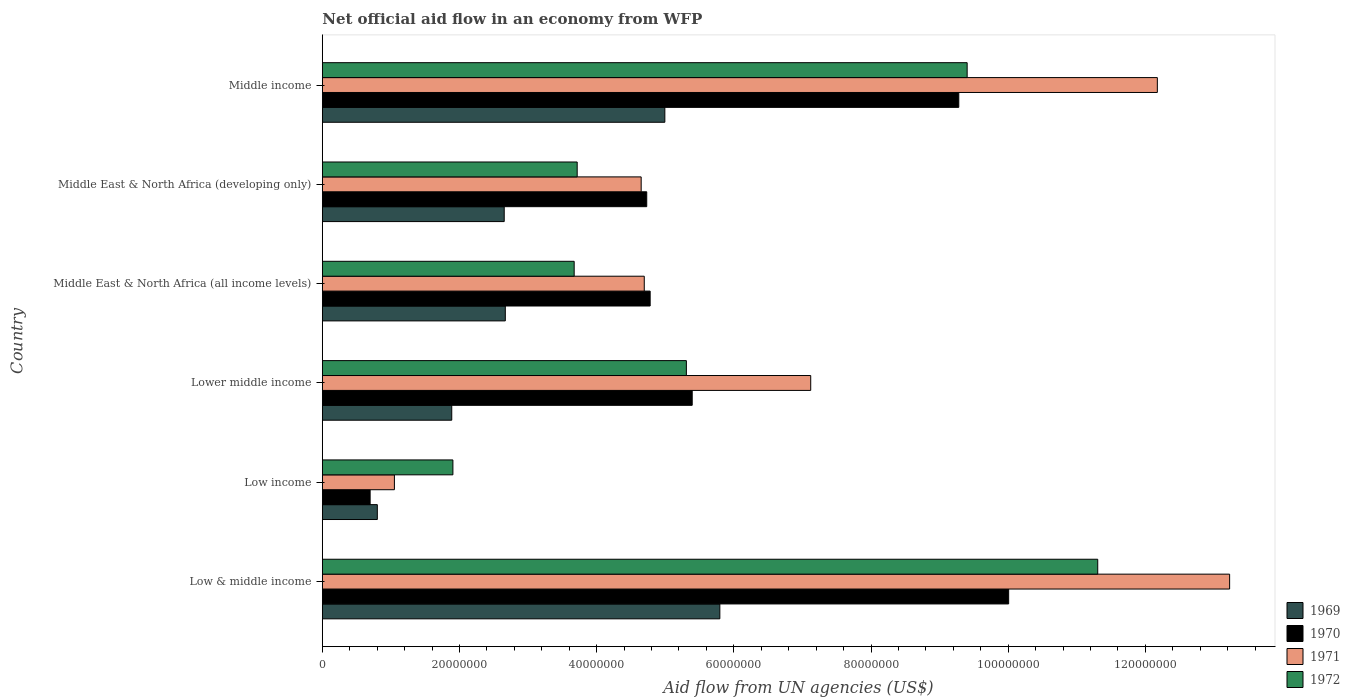Are the number of bars per tick equal to the number of legend labels?
Your answer should be very brief. Yes. Are the number of bars on each tick of the Y-axis equal?
Offer a very short reply. Yes. What is the label of the 2nd group of bars from the top?
Your answer should be compact. Middle East & North Africa (developing only). In how many cases, is the number of bars for a given country not equal to the number of legend labels?
Your answer should be very brief. 0. What is the net official aid flow in 1970 in Middle East & North Africa (developing only)?
Ensure brevity in your answer.  4.73e+07. Across all countries, what is the maximum net official aid flow in 1970?
Your answer should be very brief. 1.00e+08. Across all countries, what is the minimum net official aid flow in 1971?
Your answer should be compact. 1.05e+07. In which country was the net official aid flow in 1971 minimum?
Provide a succinct answer. Low income. What is the total net official aid flow in 1971 in the graph?
Keep it short and to the point. 4.29e+08. What is the difference between the net official aid flow in 1971 in Low income and that in Lower middle income?
Provide a short and direct response. -6.07e+07. What is the difference between the net official aid flow in 1972 in Middle income and the net official aid flow in 1969 in Middle East & North Africa (developing only)?
Your answer should be very brief. 6.75e+07. What is the average net official aid flow in 1970 per country?
Provide a succinct answer. 5.81e+07. What is the difference between the net official aid flow in 1970 and net official aid flow in 1971 in Low & middle income?
Provide a short and direct response. -3.22e+07. What is the ratio of the net official aid flow in 1969 in Low income to that in Middle income?
Your answer should be very brief. 0.16. What is the difference between the highest and the second highest net official aid flow in 1972?
Offer a very short reply. 1.90e+07. What is the difference between the highest and the lowest net official aid flow in 1971?
Your answer should be compact. 1.22e+08. What does the 1st bar from the top in Middle East & North Africa (all income levels) represents?
Give a very brief answer. 1972. What does the 2nd bar from the bottom in Lower middle income represents?
Ensure brevity in your answer.  1970. Is it the case that in every country, the sum of the net official aid flow in 1969 and net official aid flow in 1970 is greater than the net official aid flow in 1971?
Your response must be concise. Yes. How many countries are there in the graph?
Provide a short and direct response. 6. What is the difference between two consecutive major ticks on the X-axis?
Provide a short and direct response. 2.00e+07. What is the title of the graph?
Make the answer very short. Net official aid flow in an economy from WFP. Does "1990" appear as one of the legend labels in the graph?
Your response must be concise. No. What is the label or title of the X-axis?
Give a very brief answer. Aid flow from UN agencies (US$). What is the Aid flow from UN agencies (US$) in 1969 in Low & middle income?
Offer a very short reply. 5.80e+07. What is the Aid flow from UN agencies (US$) of 1970 in Low & middle income?
Keep it short and to the point. 1.00e+08. What is the Aid flow from UN agencies (US$) of 1971 in Low & middle income?
Provide a succinct answer. 1.32e+08. What is the Aid flow from UN agencies (US$) in 1972 in Low & middle income?
Your answer should be compact. 1.13e+08. What is the Aid flow from UN agencies (US$) of 1969 in Low income?
Provide a succinct answer. 8.02e+06. What is the Aid flow from UN agencies (US$) in 1970 in Low income?
Provide a succinct answer. 6.97e+06. What is the Aid flow from UN agencies (US$) of 1971 in Low income?
Make the answer very short. 1.05e+07. What is the Aid flow from UN agencies (US$) of 1972 in Low income?
Make the answer very short. 1.90e+07. What is the Aid flow from UN agencies (US$) of 1969 in Lower middle income?
Ensure brevity in your answer.  1.89e+07. What is the Aid flow from UN agencies (US$) of 1970 in Lower middle income?
Your answer should be very brief. 5.39e+07. What is the Aid flow from UN agencies (US$) of 1971 in Lower middle income?
Keep it short and to the point. 7.12e+07. What is the Aid flow from UN agencies (US$) of 1972 in Lower middle income?
Keep it short and to the point. 5.31e+07. What is the Aid flow from UN agencies (US$) in 1969 in Middle East & North Africa (all income levels)?
Offer a terse response. 2.67e+07. What is the Aid flow from UN agencies (US$) in 1970 in Middle East & North Africa (all income levels)?
Provide a short and direct response. 4.78e+07. What is the Aid flow from UN agencies (US$) in 1971 in Middle East & North Africa (all income levels)?
Your response must be concise. 4.69e+07. What is the Aid flow from UN agencies (US$) in 1972 in Middle East & North Africa (all income levels)?
Give a very brief answer. 3.67e+07. What is the Aid flow from UN agencies (US$) of 1969 in Middle East & North Africa (developing only)?
Your answer should be very brief. 2.65e+07. What is the Aid flow from UN agencies (US$) of 1970 in Middle East & North Africa (developing only)?
Your response must be concise. 4.73e+07. What is the Aid flow from UN agencies (US$) of 1971 in Middle East & North Africa (developing only)?
Make the answer very short. 4.65e+07. What is the Aid flow from UN agencies (US$) of 1972 in Middle East & North Africa (developing only)?
Your answer should be very brief. 3.72e+07. What is the Aid flow from UN agencies (US$) of 1969 in Middle income?
Provide a succinct answer. 4.99e+07. What is the Aid flow from UN agencies (US$) of 1970 in Middle income?
Give a very brief answer. 9.28e+07. What is the Aid flow from UN agencies (US$) of 1971 in Middle income?
Provide a succinct answer. 1.22e+08. What is the Aid flow from UN agencies (US$) of 1972 in Middle income?
Make the answer very short. 9.40e+07. Across all countries, what is the maximum Aid flow from UN agencies (US$) in 1969?
Make the answer very short. 5.80e+07. Across all countries, what is the maximum Aid flow from UN agencies (US$) of 1970?
Your answer should be very brief. 1.00e+08. Across all countries, what is the maximum Aid flow from UN agencies (US$) of 1971?
Offer a terse response. 1.32e+08. Across all countries, what is the maximum Aid flow from UN agencies (US$) in 1972?
Give a very brief answer. 1.13e+08. Across all countries, what is the minimum Aid flow from UN agencies (US$) in 1969?
Your response must be concise. 8.02e+06. Across all countries, what is the minimum Aid flow from UN agencies (US$) of 1970?
Your response must be concise. 6.97e+06. Across all countries, what is the minimum Aid flow from UN agencies (US$) in 1971?
Provide a succinct answer. 1.05e+07. Across all countries, what is the minimum Aid flow from UN agencies (US$) in 1972?
Your answer should be compact. 1.90e+07. What is the total Aid flow from UN agencies (US$) in 1969 in the graph?
Your answer should be compact. 1.88e+08. What is the total Aid flow from UN agencies (US$) in 1970 in the graph?
Your response must be concise. 3.49e+08. What is the total Aid flow from UN agencies (US$) in 1971 in the graph?
Give a very brief answer. 4.29e+08. What is the total Aid flow from UN agencies (US$) in 1972 in the graph?
Make the answer very short. 3.53e+08. What is the difference between the Aid flow from UN agencies (US$) of 1969 in Low & middle income and that in Low income?
Your answer should be very brief. 4.99e+07. What is the difference between the Aid flow from UN agencies (US$) of 1970 in Low & middle income and that in Low income?
Your answer should be compact. 9.31e+07. What is the difference between the Aid flow from UN agencies (US$) of 1971 in Low & middle income and that in Low income?
Provide a succinct answer. 1.22e+08. What is the difference between the Aid flow from UN agencies (US$) of 1972 in Low & middle income and that in Low income?
Make the answer very short. 9.40e+07. What is the difference between the Aid flow from UN agencies (US$) of 1969 in Low & middle income and that in Lower middle income?
Your answer should be compact. 3.91e+07. What is the difference between the Aid flow from UN agencies (US$) of 1970 in Low & middle income and that in Lower middle income?
Provide a short and direct response. 4.61e+07. What is the difference between the Aid flow from UN agencies (US$) of 1971 in Low & middle income and that in Lower middle income?
Provide a short and direct response. 6.11e+07. What is the difference between the Aid flow from UN agencies (US$) of 1972 in Low & middle income and that in Lower middle income?
Your answer should be very brief. 6.00e+07. What is the difference between the Aid flow from UN agencies (US$) of 1969 in Low & middle income and that in Middle East & North Africa (all income levels)?
Keep it short and to the point. 3.13e+07. What is the difference between the Aid flow from UN agencies (US$) of 1970 in Low & middle income and that in Middle East & North Africa (all income levels)?
Your answer should be very brief. 5.23e+07. What is the difference between the Aid flow from UN agencies (US$) in 1971 in Low & middle income and that in Middle East & North Africa (all income levels)?
Provide a succinct answer. 8.54e+07. What is the difference between the Aid flow from UN agencies (US$) of 1972 in Low & middle income and that in Middle East & North Africa (all income levels)?
Ensure brevity in your answer.  7.63e+07. What is the difference between the Aid flow from UN agencies (US$) in 1969 in Low & middle income and that in Middle East & North Africa (developing only)?
Provide a succinct answer. 3.14e+07. What is the difference between the Aid flow from UN agencies (US$) of 1970 in Low & middle income and that in Middle East & North Africa (developing only)?
Make the answer very short. 5.28e+07. What is the difference between the Aid flow from UN agencies (US$) of 1971 in Low & middle income and that in Middle East & North Africa (developing only)?
Ensure brevity in your answer.  8.58e+07. What is the difference between the Aid flow from UN agencies (US$) of 1972 in Low & middle income and that in Middle East & North Africa (developing only)?
Your answer should be compact. 7.59e+07. What is the difference between the Aid flow from UN agencies (US$) in 1969 in Low & middle income and that in Middle income?
Provide a succinct answer. 8.02e+06. What is the difference between the Aid flow from UN agencies (US$) of 1970 in Low & middle income and that in Middle income?
Provide a short and direct response. 7.27e+06. What is the difference between the Aid flow from UN agencies (US$) of 1971 in Low & middle income and that in Middle income?
Make the answer very short. 1.05e+07. What is the difference between the Aid flow from UN agencies (US$) in 1972 in Low & middle income and that in Middle income?
Give a very brief answer. 1.90e+07. What is the difference between the Aid flow from UN agencies (US$) of 1969 in Low income and that in Lower middle income?
Make the answer very short. -1.08e+07. What is the difference between the Aid flow from UN agencies (US$) in 1970 in Low income and that in Lower middle income?
Your answer should be compact. -4.70e+07. What is the difference between the Aid flow from UN agencies (US$) of 1971 in Low income and that in Lower middle income?
Your answer should be compact. -6.07e+07. What is the difference between the Aid flow from UN agencies (US$) of 1972 in Low income and that in Lower middle income?
Keep it short and to the point. -3.40e+07. What is the difference between the Aid flow from UN agencies (US$) of 1969 in Low income and that in Middle East & North Africa (all income levels)?
Ensure brevity in your answer.  -1.87e+07. What is the difference between the Aid flow from UN agencies (US$) of 1970 in Low income and that in Middle East & North Africa (all income levels)?
Offer a terse response. -4.08e+07. What is the difference between the Aid flow from UN agencies (US$) of 1971 in Low income and that in Middle East & North Africa (all income levels)?
Your answer should be very brief. -3.64e+07. What is the difference between the Aid flow from UN agencies (US$) in 1972 in Low income and that in Middle East & North Africa (all income levels)?
Give a very brief answer. -1.77e+07. What is the difference between the Aid flow from UN agencies (US$) in 1969 in Low income and that in Middle East & North Africa (developing only)?
Your answer should be compact. -1.85e+07. What is the difference between the Aid flow from UN agencies (US$) of 1970 in Low income and that in Middle East & North Africa (developing only)?
Your answer should be very brief. -4.03e+07. What is the difference between the Aid flow from UN agencies (US$) in 1971 in Low income and that in Middle East & North Africa (developing only)?
Make the answer very short. -3.60e+07. What is the difference between the Aid flow from UN agencies (US$) of 1972 in Low income and that in Middle East & North Africa (developing only)?
Give a very brief answer. -1.81e+07. What is the difference between the Aid flow from UN agencies (US$) in 1969 in Low income and that in Middle income?
Provide a succinct answer. -4.19e+07. What is the difference between the Aid flow from UN agencies (US$) in 1970 in Low income and that in Middle income?
Provide a short and direct response. -8.58e+07. What is the difference between the Aid flow from UN agencies (US$) of 1971 in Low income and that in Middle income?
Give a very brief answer. -1.11e+08. What is the difference between the Aid flow from UN agencies (US$) in 1972 in Low income and that in Middle income?
Your answer should be compact. -7.50e+07. What is the difference between the Aid flow from UN agencies (US$) in 1969 in Lower middle income and that in Middle East & North Africa (all income levels)?
Your answer should be compact. -7.81e+06. What is the difference between the Aid flow from UN agencies (US$) of 1970 in Lower middle income and that in Middle East & North Africa (all income levels)?
Offer a very short reply. 6.13e+06. What is the difference between the Aid flow from UN agencies (US$) of 1971 in Lower middle income and that in Middle East & North Africa (all income levels)?
Your answer should be very brief. 2.43e+07. What is the difference between the Aid flow from UN agencies (US$) in 1972 in Lower middle income and that in Middle East & North Africa (all income levels)?
Your answer should be compact. 1.64e+07. What is the difference between the Aid flow from UN agencies (US$) of 1969 in Lower middle income and that in Middle East & North Africa (developing only)?
Your answer should be very brief. -7.65e+06. What is the difference between the Aid flow from UN agencies (US$) of 1970 in Lower middle income and that in Middle East & North Africa (developing only)?
Give a very brief answer. 6.63e+06. What is the difference between the Aid flow from UN agencies (US$) in 1971 in Lower middle income and that in Middle East & North Africa (developing only)?
Offer a terse response. 2.47e+07. What is the difference between the Aid flow from UN agencies (US$) of 1972 in Lower middle income and that in Middle East & North Africa (developing only)?
Ensure brevity in your answer.  1.59e+07. What is the difference between the Aid flow from UN agencies (US$) of 1969 in Lower middle income and that in Middle income?
Offer a terse response. -3.11e+07. What is the difference between the Aid flow from UN agencies (US$) in 1970 in Lower middle income and that in Middle income?
Your response must be concise. -3.89e+07. What is the difference between the Aid flow from UN agencies (US$) in 1971 in Lower middle income and that in Middle income?
Give a very brief answer. -5.05e+07. What is the difference between the Aid flow from UN agencies (US$) of 1972 in Lower middle income and that in Middle income?
Offer a very short reply. -4.09e+07. What is the difference between the Aid flow from UN agencies (US$) in 1969 in Middle East & North Africa (all income levels) and that in Middle East & North Africa (developing only)?
Keep it short and to the point. 1.60e+05. What is the difference between the Aid flow from UN agencies (US$) of 1970 in Middle East & North Africa (all income levels) and that in Middle East & North Africa (developing only)?
Make the answer very short. 5.00e+05. What is the difference between the Aid flow from UN agencies (US$) of 1972 in Middle East & North Africa (all income levels) and that in Middle East & North Africa (developing only)?
Give a very brief answer. -4.40e+05. What is the difference between the Aid flow from UN agencies (US$) in 1969 in Middle East & North Africa (all income levels) and that in Middle income?
Make the answer very short. -2.33e+07. What is the difference between the Aid flow from UN agencies (US$) in 1970 in Middle East & North Africa (all income levels) and that in Middle income?
Keep it short and to the point. -4.50e+07. What is the difference between the Aid flow from UN agencies (US$) in 1971 in Middle East & North Africa (all income levels) and that in Middle income?
Keep it short and to the point. -7.48e+07. What is the difference between the Aid flow from UN agencies (US$) in 1972 in Middle East & North Africa (all income levels) and that in Middle income?
Give a very brief answer. -5.73e+07. What is the difference between the Aid flow from UN agencies (US$) of 1969 in Middle East & North Africa (developing only) and that in Middle income?
Offer a terse response. -2.34e+07. What is the difference between the Aid flow from UN agencies (US$) in 1970 in Middle East & North Africa (developing only) and that in Middle income?
Keep it short and to the point. -4.55e+07. What is the difference between the Aid flow from UN agencies (US$) in 1971 in Middle East & North Africa (developing only) and that in Middle income?
Your answer should be very brief. -7.53e+07. What is the difference between the Aid flow from UN agencies (US$) in 1972 in Middle East & North Africa (developing only) and that in Middle income?
Your response must be concise. -5.69e+07. What is the difference between the Aid flow from UN agencies (US$) of 1969 in Low & middle income and the Aid flow from UN agencies (US$) of 1970 in Low income?
Give a very brief answer. 5.10e+07. What is the difference between the Aid flow from UN agencies (US$) of 1969 in Low & middle income and the Aid flow from UN agencies (US$) of 1971 in Low income?
Your answer should be very brief. 4.74e+07. What is the difference between the Aid flow from UN agencies (US$) of 1969 in Low & middle income and the Aid flow from UN agencies (US$) of 1972 in Low income?
Give a very brief answer. 3.89e+07. What is the difference between the Aid flow from UN agencies (US$) of 1970 in Low & middle income and the Aid flow from UN agencies (US$) of 1971 in Low income?
Provide a short and direct response. 8.96e+07. What is the difference between the Aid flow from UN agencies (US$) in 1970 in Low & middle income and the Aid flow from UN agencies (US$) in 1972 in Low income?
Ensure brevity in your answer.  8.10e+07. What is the difference between the Aid flow from UN agencies (US$) of 1971 in Low & middle income and the Aid flow from UN agencies (US$) of 1972 in Low income?
Provide a short and direct response. 1.13e+08. What is the difference between the Aid flow from UN agencies (US$) of 1969 in Low & middle income and the Aid flow from UN agencies (US$) of 1970 in Lower middle income?
Offer a terse response. 4.03e+06. What is the difference between the Aid flow from UN agencies (US$) of 1969 in Low & middle income and the Aid flow from UN agencies (US$) of 1971 in Lower middle income?
Your answer should be very brief. -1.32e+07. What is the difference between the Aid flow from UN agencies (US$) in 1969 in Low & middle income and the Aid flow from UN agencies (US$) in 1972 in Lower middle income?
Ensure brevity in your answer.  4.88e+06. What is the difference between the Aid flow from UN agencies (US$) of 1970 in Low & middle income and the Aid flow from UN agencies (US$) of 1971 in Lower middle income?
Offer a very short reply. 2.89e+07. What is the difference between the Aid flow from UN agencies (US$) of 1970 in Low & middle income and the Aid flow from UN agencies (US$) of 1972 in Lower middle income?
Your response must be concise. 4.70e+07. What is the difference between the Aid flow from UN agencies (US$) in 1971 in Low & middle income and the Aid flow from UN agencies (US$) in 1972 in Lower middle income?
Provide a short and direct response. 7.92e+07. What is the difference between the Aid flow from UN agencies (US$) of 1969 in Low & middle income and the Aid flow from UN agencies (US$) of 1970 in Middle East & North Africa (all income levels)?
Offer a terse response. 1.02e+07. What is the difference between the Aid flow from UN agencies (US$) in 1969 in Low & middle income and the Aid flow from UN agencies (US$) in 1971 in Middle East & North Africa (all income levels)?
Your answer should be compact. 1.10e+07. What is the difference between the Aid flow from UN agencies (US$) of 1969 in Low & middle income and the Aid flow from UN agencies (US$) of 1972 in Middle East & North Africa (all income levels)?
Provide a succinct answer. 2.12e+07. What is the difference between the Aid flow from UN agencies (US$) in 1970 in Low & middle income and the Aid flow from UN agencies (US$) in 1971 in Middle East & North Africa (all income levels)?
Your answer should be compact. 5.31e+07. What is the difference between the Aid flow from UN agencies (US$) in 1970 in Low & middle income and the Aid flow from UN agencies (US$) in 1972 in Middle East & North Africa (all income levels)?
Offer a terse response. 6.34e+07. What is the difference between the Aid flow from UN agencies (US$) of 1971 in Low & middle income and the Aid flow from UN agencies (US$) of 1972 in Middle East & North Africa (all income levels)?
Give a very brief answer. 9.56e+07. What is the difference between the Aid flow from UN agencies (US$) in 1969 in Low & middle income and the Aid flow from UN agencies (US$) in 1970 in Middle East & North Africa (developing only)?
Your answer should be very brief. 1.07e+07. What is the difference between the Aid flow from UN agencies (US$) of 1969 in Low & middle income and the Aid flow from UN agencies (US$) of 1971 in Middle East & North Africa (developing only)?
Offer a very short reply. 1.15e+07. What is the difference between the Aid flow from UN agencies (US$) of 1969 in Low & middle income and the Aid flow from UN agencies (US$) of 1972 in Middle East & North Africa (developing only)?
Provide a short and direct response. 2.08e+07. What is the difference between the Aid flow from UN agencies (US$) of 1970 in Low & middle income and the Aid flow from UN agencies (US$) of 1971 in Middle East & North Africa (developing only)?
Give a very brief answer. 5.36e+07. What is the difference between the Aid flow from UN agencies (US$) of 1970 in Low & middle income and the Aid flow from UN agencies (US$) of 1972 in Middle East & North Africa (developing only)?
Offer a very short reply. 6.29e+07. What is the difference between the Aid flow from UN agencies (US$) in 1971 in Low & middle income and the Aid flow from UN agencies (US$) in 1972 in Middle East & North Africa (developing only)?
Your response must be concise. 9.51e+07. What is the difference between the Aid flow from UN agencies (US$) of 1969 in Low & middle income and the Aid flow from UN agencies (US$) of 1970 in Middle income?
Your response must be concise. -3.48e+07. What is the difference between the Aid flow from UN agencies (US$) of 1969 in Low & middle income and the Aid flow from UN agencies (US$) of 1971 in Middle income?
Your answer should be compact. -6.38e+07. What is the difference between the Aid flow from UN agencies (US$) in 1969 in Low & middle income and the Aid flow from UN agencies (US$) in 1972 in Middle income?
Offer a terse response. -3.61e+07. What is the difference between the Aid flow from UN agencies (US$) of 1970 in Low & middle income and the Aid flow from UN agencies (US$) of 1971 in Middle income?
Offer a very short reply. -2.17e+07. What is the difference between the Aid flow from UN agencies (US$) in 1970 in Low & middle income and the Aid flow from UN agencies (US$) in 1972 in Middle income?
Your response must be concise. 6.05e+06. What is the difference between the Aid flow from UN agencies (US$) of 1971 in Low & middle income and the Aid flow from UN agencies (US$) of 1972 in Middle income?
Make the answer very short. 3.83e+07. What is the difference between the Aid flow from UN agencies (US$) of 1969 in Low income and the Aid flow from UN agencies (US$) of 1970 in Lower middle income?
Offer a terse response. -4.59e+07. What is the difference between the Aid flow from UN agencies (US$) of 1969 in Low income and the Aid flow from UN agencies (US$) of 1971 in Lower middle income?
Your answer should be compact. -6.32e+07. What is the difference between the Aid flow from UN agencies (US$) of 1969 in Low income and the Aid flow from UN agencies (US$) of 1972 in Lower middle income?
Your answer should be very brief. -4.51e+07. What is the difference between the Aid flow from UN agencies (US$) in 1970 in Low income and the Aid flow from UN agencies (US$) in 1971 in Lower middle income?
Ensure brevity in your answer.  -6.42e+07. What is the difference between the Aid flow from UN agencies (US$) in 1970 in Low income and the Aid flow from UN agencies (US$) in 1972 in Lower middle income?
Keep it short and to the point. -4.61e+07. What is the difference between the Aid flow from UN agencies (US$) in 1971 in Low income and the Aid flow from UN agencies (US$) in 1972 in Lower middle income?
Make the answer very short. -4.26e+07. What is the difference between the Aid flow from UN agencies (US$) of 1969 in Low income and the Aid flow from UN agencies (US$) of 1970 in Middle East & North Africa (all income levels)?
Keep it short and to the point. -3.98e+07. What is the difference between the Aid flow from UN agencies (US$) in 1969 in Low income and the Aid flow from UN agencies (US$) in 1971 in Middle East & North Africa (all income levels)?
Give a very brief answer. -3.89e+07. What is the difference between the Aid flow from UN agencies (US$) in 1969 in Low income and the Aid flow from UN agencies (US$) in 1972 in Middle East & North Africa (all income levels)?
Give a very brief answer. -2.87e+07. What is the difference between the Aid flow from UN agencies (US$) of 1970 in Low income and the Aid flow from UN agencies (US$) of 1971 in Middle East & North Africa (all income levels)?
Offer a very short reply. -4.00e+07. What is the difference between the Aid flow from UN agencies (US$) of 1970 in Low income and the Aid flow from UN agencies (US$) of 1972 in Middle East & North Africa (all income levels)?
Offer a terse response. -2.98e+07. What is the difference between the Aid flow from UN agencies (US$) of 1971 in Low income and the Aid flow from UN agencies (US$) of 1972 in Middle East & North Africa (all income levels)?
Your answer should be compact. -2.62e+07. What is the difference between the Aid flow from UN agencies (US$) in 1969 in Low income and the Aid flow from UN agencies (US$) in 1970 in Middle East & North Africa (developing only)?
Make the answer very short. -3.93e+07. What is the difference between the Aid flow from UN agencies (US$) of 1969 in Low income and the Aid flow from UN agencies (US$) of 1971 in Middle East & North Africa (developing only)?
Give a very brief answer. -3.85e+07. What is the difference between the Aid flow from UN agencies (US$) in 1969 in Low income and the Aid flow from UN agencies (US$) in 1972 in Middle East & North Africa (developing only)?
Provide a succinct answer. -2.91e+07. What is the difference between the Aid flow from UN agencies (US$) in 1970 in Low income and the Aid flow from UN agencies (US$) in 1971 in Middle East & North Africa (developing only)?
Your answer should be compact. -3.95e+07. What is the difference between the Aid flow from UN agencies (US$) in 1970 in Low income and the Aid flow from UN agencies (US$) in 1972 in Middle East & North Africa (developing only)?
Your response must be concise. -3.02e+07. What is the difference between the Aid flow from UN agencies (US$) in 1971 in Low income and the Aid flow from UN agencies (US$) in 1972 in Middle East & North Africa (developing only)?
Keep it short and to the point. -2.66e+07. What is the difference between the Aid flow from UN agencies (US$) in 1969 in Low income and the Aid flow from UN agencies (US$) in 1970 in Middle income?
Provide a short and direct response. -8.48e+07. What is the difference between the Aid flow from UN agencies (US$) in 1969 in Low income and the Aid flow from UN agencies (US$) in 1971 in Middle income?
Ensure brevity in your answer.  -1.14e+08. What is the difference between the Aid flow from UN agencies (US$) of 1969 in Low income and the Aid flow from UN agencies (US$) of 1972 in Middle income?
Your answer should be very brief. -8.60e+07. What is the difference between the Aid flow from UN agencies (US$) in 1970 in Low income and the Aid flow from UN agencies (US$) in 1971 in Middle income?
Your answer should be very brief. -1.15e+08. What is the difference between the Aid flow from UN agencies (US$) in 1970 in Low income and the Aid flow from UN agencies (US$) in 1972 in Middle income?
Your answer should be very brief. -8.70e+07. What is the difference between the Aid flow from UN agencies (US$) in 1971 in Low income and the Aid flow from UN agencies (US$) in 1972 in Middle income?
Provide a short and direct response. -8.35e+07. What is the difference between the Aid flow from UN agencies (US$) of 1969 in Lower middle income and the Aid flow from UN agencies (US$) of 1970 in Middle East & North Africa (all income levels)?
Give a very brief answer. -2.89e+07. What is the difference between the Aid flow from UN agencies (US$) in 1969 in Lower middle income and the Aid flow from UN agencies (US$) in 1971 in Middle East & North Africa (all income levels)?
Ensure brevity in your answer.  -2.81e+07. What is the difference between the Aid flow from UN agencies (US$) of 1969 in Lower middle income and the Aid flow from UN agencies (US$) of 1972 in Middle East & North Africa (all income levels)?
Make the answer very short. -1.78e+07. What is the difference between the Aid flow from UN agencies (US$) of 1970 in Lower middle income and the Aid flow from UN agencies (US$) of 1971 in Middle East & North Africa (all income levels)?
Give a very brief answer. 6.99e+06. What is the difference between the Aid flow from UN agencies (US$) in 1970 in Lower middle income and the Aid flow from UN agencies (US$) in 1972 in Middle East & North Africa (all income levels)?
Offer a very short reply. 1.72e+07. What is the difference between the Aid flow from UN agencies (US$) of 1971 in Lower middle income and the Aid flow from UN agencies (US$) of 1972 in Middle East & North Africa (all income levels)?
Give a very brief answer. 3.45e+07. What is the difference between the Aid flow from UN agencies (US$) of 1969 in Lower middle income and the Aid flow from UN agencies (US$) of 1970 in Middle East & North Africa (developing only)?
Give a very brief answer. -2.84e+07. What is the difference between the Aid flow from UN agencies (US$) in 1969 in Lower middle income and the Aid flow from UN agencies (US$) in 1971 in Middle East & North Africa (developing only)?
Offer a terse response. -2.76e+07. What is the difference between the Aid flow from UN agencies (US$) of 1969 in Lower middle income and the Aid flow from UN agencies (US$) of 1972 in Middle East & North Africa (developing only)?
Keep it short and to the point. -1.83e+07. What is the difference between the Aid flow from UN agencies (US$) of 1970 in Lower middle income and the Aid flow from UN agencies (US$) of 1971 in Middle East & North Africa (developing only)?
Keep it short and to the point. 7.44e+06. What is the difference between the Aid flow from UN agencies (US$) of 1970 in Lower middle income and the Aid flow from UN agencies (US$) of 1972 in Middle East & North Africa (developing only)?
Your answer should be compact. 1.68e+07. What is the difference between the Aid flow from UN agencies (US$) of 1971 in Lower middle income and the Aid flow from UN agencies (US$) of 1972 in Middle East & North Africa (developing only)?
Make the answer very short. 3.40e+07. What is the difference between the Aid flow from UN agencies (US$) of 1969 in Lower middle income and the Aid flow from UN agencies (US$) of 1970 in Middle income?
Keep it short and to the point. -7.39e+07. What is the difference between the Aid flow from UN agencies (US$) of 1969 in Lower middle income and the Aid flow from UN agencies (US$) of 1971 in Middle income?
Give a very brief answer. -1.03e+08. What is the difference between the Aid flow from UN agencies (US$) in 1969 in Lower middle income and the Aid flow from UN agencies (US$) in 1972 in Middle income?
Provide a succinct answer. -7.52e+07. What is the difference between the Aid flow from UN agencies (US$) in 1970 in Lower middle income and the Aid flow from UN agencies (US$) in 1971 in Middle income?
Offer a very short reply. -6.78e+07. What is the difference between the Aid flow from UN agencies (US$) in 1970 in Lower middle income and the Aid flow from UN agencies (US$) in 1972 in Middle income?
Make the answer very short. -4.01e+07. What is the difference between the Aid flow from UN agencies (US$) of 1971 in Lower middle income and the Aid flow from UN agencies (US$) of 1972 in Middle income?
Your response must be concise. -2.28e+07. What is the difference between the Aid flow from UN agencies (US$) of 1969 in Middle East & North Africa (all income levels) and the Aid flow from UN agencies (US$) of 1970 in Middle East & North Africa (developing only)?
Your response must be concise. -2.06e+07. What is the difference between the Aid flow from UN agencies (US$) of 1969 in Middle East & North Africa (all income levels) and the Aid flow from UN agencies (US$) of 1971 in Middle East & North Africa (developing only)?
Keep it short and to the point. -1.98e+07. What is the difference between the Aid flow from UN agencies (US$) of 1969 in Middle East & North Africa (all income levels) and the Aid flow from UN agencies (US$) of 1972 in Middle East & North Africa (developing only)?
Your answer should be compact. -1.05e+07. What is the difference between the Aid flow from UN agencies (US$) in 1970 in Middle East & North Africa (all income levels) and the Aid flow from UN agencies (US$) in 1971 in Middle East & North Africa (developing only)?
Offer a very short reply. 1.31e+06. What is the difference between the Aid flow from UN agencies (US$) of 1970 in Middle East & North Africa (all income levels) and the Aid flow from UN agencies (US$) of 1972 in Middle East & North Africa (developing only)?
Your answer should be compact. 1.06e+07. What is the difference between the Aid flow from UN agencies (US$) in 1971 in Middle East & North Africa (all income levels) and the Aid flow from UN agencies (US$) in 1972 in Middle East & North Africa (developing only)?
Provide a succinct answer. 9.78e+06. What is the difference between the Aid flow from UN agencies (US$) in 1969 in Middle East & North Africa (all income levels) and the Aid flow from UN agencies (US$) in 1970 in Middle income?
Keep it short and to the point. -6.61e+07. What is the difference between the Aid flow from UN agencies (US$) in 1969 in Middle East & North Africa (all income levels) and the Aid flow from UN agencies (US$) in 1971 in Middle income?
Ensure brevity in your answer.  -9.51e+07. What is the difference between the Aid flow from UN agencies (US$) in 1969 in Middle East & North Africa (all income levels) and the Aid flow from UN agencies (US$) in 1972 in Middle income?
Give a very brief answer. -6.73e+07. What is the difference between the Aid flow from UN agencies (US$) in 1970 in Middle East & North Africa (all income levels) and the Aid flow from UN agencies (US$) in 1971 in Middle income?
Offer a terse response. -7.40e+07. What is the difference between the Aid flow from UN agencies (US$) of 1970 in Middle East & North Africa (all income levels) and the Aid flow from UN agencies (US$) of 1972 in Middle income?
Provide a succinct answer. -4.62e+07. What is the difference between the Aid flow from UN agencies (US$) in 1971 in Middle East & North Africa (all income levels) and the Aid flow from UN agencies (US$) in 1972 in Middle income?
Ensure brevity in your answer.  -4.71e+07. What is the difference between the Aid flow from UN agencies (US$) of 1969 in Middle East & North Africa (developing only) and the Aid flow from UN agencies (US$) of 1970 in Middle income?
Provide a short and direct response. -6.63e+07. What is the difference between the Aid flow from UN agencies (US$) in 1969 in Middle East & North Africa (developing only) and the Aid flow from UN agencies (US$) in 1971 in Middle income?
Keep it short and to the point. -9.52e+07. What is the difference between the Aid flow from UN agencies (US$) of 1969 in Middle East & North Africa (developing only) and the Aid flow from UN agencies (US$) of 1972 in Middle income?
Make the answer very short. -6.75e+07. What is the difference between the Aid flow from UN agencies (US$) of 1970 in Middle East & North Africa (developing only) and the Aid flow from UN agencies (US$) of 1971 in Middle income?
Ensure brevity in your answer.  -7.44e+07. What is the difference between the Aid flow from UN agencies (US$) of 1970 in Middle East & North Africa (developing only) and the Aid flow from UN agencies (US$) of 1972 in Middle income?
Provide a short and direct response. -4.67e+07. What is the difference between the Aid flow from UN agencies (US$) of 1971 in Middle East & North Africa (developing only) and the Aid flow from UN agencies (US$) of 1972 in Middle income?
Offer a very short reply. -4.75e+07. What is the average Aid flow from UN agencies (US$) of 1969 per country?
Your answer should be compact. 3.13e+07. What is the average Aid flow from UN agencies (US$) in 1970 per country?
Your answer should be compact. 5.81e+07. What is the average Aid flow from UN agencies (US$) of 1971 per country?
Ensure brevity in your answer.  7.15e+07. What is the average Aid flow from UN agencies (US$) in 1972 per country?
Make the answer very short. 5.88e+07. What is the difference between the Aid flow from UN agencies (US$) of 1969 and Aid flow from UN agencies (US$) of 1970 in Low & middle income?
Your answer should be very brief. -4.21e+07. What is the difference between the Aid flow from UN agencies (US$) of 1969 and Aid flow from UN agencies (US$) of 1971 in Low & middle income?
Your answer should be very brief. -7.43e+07. What is the difference between the Aid flow from UN agencies (US$) in 1969 and Aid flow from UN agencies (US$) in 1972 in Low & middle income?
Your answer should be very brief. -5.51e+07. What is the difference between the Aid flow from UN agencies (US$) of 1970 and Aid flow from UN agencies (US$) of 1971 in Low & middle income?
Provide a succinct answer. -3.22e+07. What is the difference between the Aid flow from UN agencies (US$) of 1970 and Aid flow from UN agencies (US$) of 1972 in Low & middle income?
Provide a short and direct response. -1.30e+07. What is the difference between the Aid flow from UN agencies (US$) in 1971 and Aid flow from UN agencies (US$) in 1972 in Low & middle income?
Make the answer very short. 1.92e+07. What is the difference between the Aid flow from UN agencies (US$) of 1969 and Aid flow from UN agencies (US$) of 1970 in Low income?
Keep it short and to the point. 1.05e+06. What is the difference between the Aid flow from UN agencies (US$) in 1969 and Aid flow from UN agencies (US$) in 1971 in Low income?
Provide a succinct answer. -2.49e+06. What is the difference between the Aid flow from UN agencies (US$) of 1969 and Aid flow from UN agencies (US$) of 1972 in Low income?
Make the answer very short. -1.10e+07. What is the difference between the Aid flow from UN agencies (US$) of 1970 and Aid flow from UN agencies (US$) of 1971 in Low income?
Offer a very short reply. -3.54e+06. What is the difference between the Aid flow from UN agencies (US$) in 1970 and Aid flow from UN agencies (US$) in 1972 in Low income?
Make the answer very short. -1.21e+07. What is the difference between the Aid flow from UN agencies (US$) of 1971 and Aid flow from UN agencies (US$) of 1972 in Low income?
Your answer should be compact. -8.53e+06. What is the difference between the Aid flow from UN agencies (US$) in 1969 and Aid flow from UN agencies (US$) in 1970 in Lower middle income?
Your answer should be compact. -3.51e+07. What is the difference between the Aid flow from UN agencies (US$) in 1969 and Aid flow from UN agencies (US$) in 1971 in Lower middle income?
Ensure brevity in your answer.  -5.23e+07. What is the difference between the Aid flow from UN agencies (US$) of 1969 and Aid flow from UN agencies (US$) of 1972 in Lower middle income?
Ensure brevity in your answer.  -3.42e+07. What is the difference between the Aid flow from UN agencies (US$) in 1970 and Aid flow from UN agencies (US$) in 1971 in Lower middle income?
Provide a succinct answer. -1.73e+07. What is the difference between the Aid flow from UN agencies (US$) in 1970 and Aid flow from UN agencies (US$) in 1972 in Lower middle income?
Provide a short and direct response. 8.50e+05. What is the difference between the Aid flow from UN agencies (US$) in 1971 and Aid flow from UN agencies (US$) in 1972 in Lower middle income?
Provide a short and direct response. 1.81e+07. What is the difference between the Aid flow from UN agencies (US$) in 1969 and Aid flow from UN agencies (US$) in 1970 in Middle East & North Africa (all income levels)?
Offer a very short reply. -2.11e+07. What is the difference between the Aid flow from UN agencies (US$) of 1969 and Aid flow from UN agencies (US$) of 1971 in Middle East & North Africa (all income levels)?
Provide a short and direct response. -2.03e+07. What is the difference between the Aid flow from UN agencies (US$) in 1969 and Aid flow from UN agencies (US$) in 1972 in Middle East & North Africa (all income levels)?
Offer a terse response. -1.00e+07. What is the difference between the Aid flow from UN agencies (US$) in 1970 and Aid flow from UN agencies (US$) in 1971 in Middle East & North Africa (all income levels)?
Your answer should be very brief. 8.60e+05. What is the difference between the Aid flow from UN agencies (US$) in 1970 and Aid flow from UN agencies (US$) in 1972 in Middle East & North Africa (all income levels)?
Provide a succinct answer. 1.11e+07. What is the difference between the Aid flow from UN agencies (US$) in 1971 and Aid flow from UN agencies (US$) in 1972 in Middle East & North Africa (all income levels)?
Provide a short and direct response. 1.02e+07. What is the difference between the Aid flow from UN agencies (US$) in 1969 and Aid flow from UN agencies (US$) in 1970 in Middle East & North Africa (developing only)?
Ensure brevity in your answer.  -2.08e+07. What is the difference between the Aid flow from UN agencies (US$) of 1969 and Aid flow from UN agencies (US$) of 1971 in Middle East & North Africa (developing only)?
Give a very brief answer. -2.00e+07. What is the difference between the Aid flow from UN agencies (US$) in 1969 and Aid flow from UN agencies (US$) in 1972 in Middle East & North Africa (developing only)?
Your response must be concise. -1.06e+07. What is the difference between the Aid flow from UN agencies (US$) of 1970 and Aid flow from UN agencies (US$) of 1971 in Middle East & North Africa (developing only)?
Your answer should be very brief. 8.10e+05. What is the difference between the Aid flow from UN agencies (US$) of 1970 and Aid flow from UN agencies (US$) of 1972 in Middle East & North Africa (developing only)?
Provide a short and direct response. 1.01e+07. What is the difference between the Aid flow from UN agencies (US$) of 1971 and Aid flow from UN agencies (US$) of 1972 in Middle East & North Africa (developing only)?
Offer a very short reply. 9.33e+06. What is the difference between the Aid flow from UN agencies (US$) in 1969 and Aid flow from UN agencies (US$) in 1970 in Middle income?
Offer a very short reply. -4.29e+07. What is the difference between the Aid flow from UN agencies (US$) of 1969 and Aid flow from UN agencies (US$) of 1971 in Middle income?
Your answer should be very brief. -7.18e+07. What is the difference between the Aid flow from UN agencies (US$) in 1969 and Aid flow from UN agencies (US$) in 1972 in Middle income?
Your response must be concise. -4.41e+07. What is the difference between the Aid flow from UN agencies (US$) of 1970 and Aid flow from UN agencies (US$) of 1971 in Middle income?
Your response must be concise. -2.90e+07. What is the difference between the Aid flow from UN agencies (US$) in 1970 and Aid flow from UN agencies (US$) in 1972 in Middle income?
Your answer should be very brief. -1.22e+06. What is the difference between the Aid flow from UN agencies (US$) of 1971 and Aid flow from UN agencies (US$) of 1972 in Middle income?
Make the answer very short. 2.77e+07. What is the ratio of the Aid flow from UN agencies (US$) in 1969 in Low & middle income to that in Low income?
Your answer should be compact. 7.23. What is the ratio of the Aid flow from UN agencies (US$) in 1970 in Low & middle income to that in Low income?
Give a very brief answer. 14.36. What is the ratio of the Aid flow from UN agencies (US$) in 1971 in Low & middle income to that in Low income?
Make the answer very short. 12.59. What is the ratio of the Aid flow from UN agencies (US$) of 1972 in Low & middle income to that in Low income?
Keep it short and to the point. 5.94. What is the ratio of the Aid flow from UN agencies (US$) in 1969 in Low & middle income to that in Lower middle income?
Your response must be concise. 3.07. What is the ratio of the Aid flow from UN agencies (US$) of 1970 in Low & middle income to that in Lower middle income?
Offer a terse response. 1.86. What is the ratio of the Aid flow from UN agencies (US$) in 1971 in Low & middle income to that in Lower middle income?
Ensure brevity in your answer.  1.86. What is the ratio of the Aid flow from UN agencies (US$) of 1972 in Low & middle income to that in Lower middle income?
Provide a succinct answer. 2.13. What is the ratio of the Aid flow from UN agencies (US$) of 1969 in Low & middle income to that in Middle East & North Africa (all income levels)?
Keep it short and to the point. 2.17. What is the ratio of the Aid flow from UN agencies (US$) in 1970 in Low & middle income to that in Middle East & North Africa (all income levels)?
Ensure brevity in your answer.  2.09. What is the ratio of the Aid flow from UN agencies (US$) of 1971 in Low & middle income to that in Middle East & North Africa (all income levels)?
Offer a terse response. 2.82. What is the ratio of the Aid flow from UN agencies (US$) of 1972 in Low & middle income to that in Middle East & North Africa (all income levels)?
Provide a succinct answer. 3.08. What is the ratio of the Aid flow from UN agencies (US$) in 1969 in Low & middle income to that in Middle East & North Africa (developing only)?
Your answer should be very brief. 2.19. What is the ratio of the Aid flow from UN agencies (US$) in 1970 in Low & middle income to that in Middle East & North Africa (developing only)?
Your response must be concise. 2.12. What is the ratio of the Aid flow from UN agencies (US$) of 1971 in Low & middle income to that in Middle East & North Africa (developing only)?
Offer a very short reply. 2.85. What is the ratio of the Aid flow from UN agencies (US$) in 1972 in Low & middle income to that in Middle East & North Africa (developing only)?
Ensure brevity in your answer.  3.04. What is the ratio of the Aid flow from UN agencies (US$) of 1969 in Low & middle income to that in Middle income?
Ensure brevity in your answer.  1.16. What is the ratio of the Aid flow from UN agencies (US$) in 1970 in Low & middle income to that in Middle income?
Ensure brevity in your answer.  1.08. What is the ratio of the Aid flow from UN agencies (US$) of 1971 in Low & middle income to that in Middle income?
Offer a terse response. 1.09. What is the ratio of the Aid flow from UN agencies (US$) of 1972 in Low & middle income to that in Middle income?
Provide a succinct answer. 1.2. What is the ratio of the Aid flow from UN agencies (US$) of 1969 in Low income to that in Lower middle income?
Provide a short and direct response. 0.42. What is the ratio of the Aid flow from UN agencies (US$) of 1970 in Low income to that in Lower middle income?
Provide a short and direct response. 0.13. What is the ratio of the Aid flow from UN agencies (US$) in 1971 in Low income to that in Lower middle income?
Ensure brevity in your answer.  0.15. What is the ratio of the Aid flow from UN agencies (US$) of 1972 in Low income to that in Lower middle income?
Your answer should be very brief. 0.36. What is the ratio of the Aid flow from UN agencies (US$) of 1969 in Low income to that in Middle East & North Africa (all income levels)?
Your answer should be compact. 0.3. What is the ratio of the Aid flow from UN agencies (US$) of 1970 in Low income to that in Middle East & North Africa (all income levels)?
Make the answer very short. 0.15. What is the ratio of the Aid flow from UN agencies (US$) in 1971 in Low income to that in Middle East & North Africa (all income levels)?
Offer a very short reply. 0.22. What is the ratio of the Aid flow from UN agencies (US$) of 1972 in Low income to that in Middle East & North Africa (all income levels)?
Make the answer very short. 0.52. What is the ratio of the Aid flow from UN agencies (US$) of 1969 in Low income to that in Middle East & North Africa (developing only)?
Offer a very short reply. 0.3. What is the ratio of the Aid flow from UN agencies (US$) of 1970 in Low income to that in Middle East & North Africa (developing only)?
Ensure brevity in your answer.  0.15. What is the ratio of the Aid flow from UN agencies (US$) of 1971 in Low income to that in Middle East & North Africa (developing only)?
Your response must be concise. 0.23. What is the ratio of the Aid flow from UN agencies (US$) of 1972 in Low income to that in Middle East & North Africa (developing only)?
Your response must be concise. 0.51. What is the ratio of the Aid flow from UN agencies (US$) in 1969 in Low income to that in Middle income?
Provide a succinct answer. 0.16. What is the ratio of the Aid flow from UN agencies (US$) in 1970 in Low income to that in Middle income?
Give a very brief answer. 0.08. What is the ratio of the Aid flow from UN agencies (US$) of 1971 in Low income to that in Middle income?
Your response must be concise. 0.09. What is the ratio of the Aid flow from UN agencies (US$) of 1972 in Low income to that in Middle income?
Keep it short and to the point. 0.2. What is the ratio of the Aid flow from UN agencies (US$) in 1969 in Lower middle income to that in Middle East & North Africa (all income levels)?
Ensure brevity in your answer.  0.71. What is the ratio of the Aid flow from UN agencies (US$) of 1970 in Lower middle income to that in Middle East & North Africa (all income levels)?
Provide a short and direct response. 1.13. What is the ratio of the Aid flow from UN agencies (US$) in 1971 in Lower middle income to that in Middle East & North Africa (all income levels)?
Your response must be concise. 1.52. What is the ratio of the Aid flow from UN agencies (US$) in 1972 in Lower middle income to that in Middle East & North Africa (all income levels)?
Offer a very short reply. 1.45. What is the ratio of the Aid flow from UN agencies (US$) of 1969 in Lower middle income to that in Middle East & North Africa (developing only)?
Offer a terse response. 0.71. What is the ratio of the Aid flow from UN agencies (US$) in 1970 in Lower middle income to that in Middle East & North Africa (developing only)?
Keep it short and to the point. 1.14. What is the ratio of the Aid flow from UN agencies (US$) of 1971 in Lower middle income to that in Middle East & North Africa (developing only)?
Your answer should be very brief. 1.53. What is the ratio of the Aid flow from UN agencies (US$) of 1972 in Lower middle income to that in Middle East & North Africa (developing only)?
Ensure brevity in your answer.  1.43. What is the ratio of the Aid flow from UN agencies (US$) in 1969 in Lower middle income to that in Middle income?
Provide a short and direct response. 0.38. What is the ratio of the Aid flow from UN agencies (US$) in 1970 in Lower middle income to that in Middle income?
Offer a very short reply. 0.58. What is the ratio of the Aid flow from UN agencies (US$) of 1971 in Lower middle income to that in Middle income?
Offer a terse response. 0.58. What is the ratio of the Aid flow from UN agencies (US$) of 1972 in Lower middle income to that in Middle income?
Your answer should be compact. 0.56. What is the ratio of the Aid flow from UN agencies (US$) of 1970 in Middle East & North Africa (all income levels) to that in Middle East & North Africa (developing only)?
Offer a terse response. 1.01. What is the ratio of the Aid flow from UN agencies (US$) in 1971 in Middle East & North Africa (all income levels) to that in Middle East & North Africa (developing only)?
Provide a short and direct response. 1.01. What is the ratio of the Aid flow from UN agencies (US$) in 1972 in Middle East & North Africa (all income levels) to that in Middle East & North Africa (developing only)?
Ensure brevity in your answer.  0.99. What is the ratio of the Aid flow from UN agencies (US$) in 1969 in Middle East & North Africa (all income levels) to that in Middle income?
Give a very brief answer. 0.53. What is the ratio of the Aid flow from UN agencies (US$) of 1970 in Middle East & North Africa (all income levels) to that in Middle income?
Your answer should be very brief. 0.52. What is the ratio of the Aid flow from UN agencies (US$) in 1971 in Middle East & North Africa (all income levels) to that in Middle income?
Provide a short and direct response. 0.39. What is the ratio of the Aid flow from UN agencies (US$) in 1972 in Middle East & North Africa (all income levels) to that in Middle income?
Your answer should be compact. 0.39. What is the ratio of the Aid flow from UN agencies (US$) in 1969 in Middle East & North Africa (developing only) to that in Middle income?
Ensure brevity in your answer.  0.53. What is the ratio of the Aid flow from UN agencies (US$) in 1970 in Middle East & North Africa (developing only) to that in Middle income?
Your response must be concise. 0.51. What is the ratio of the Aid flow from UN agencies (US$) of 1971 in Middle East & North Africa (developing only) to that in Middle income?
Offer a very short reply. 0.38. What is the ratio of the Aid flow from UN agencies (US$) in 1972 in Middle East & North Africa (developing only) to that in Middle income?
Provide a short and direct response. 0.4. What is the difference between the highest and the second highest Aid flow from UN agencies (US$) of 1969?
Make the answer very short. 8.02e+06. What is the difference between the highest and the second highest Aid flow from UN agencies (US$) of 1970?
Ensure brevity in your answer.  7.27e+06. What is the difference between the highest and the second highest Aid flow from UN agencies (US$) of 1971?
Your answer should be very brief. 1.05e+07. What is the difference between the highest and the second highest Aid flow from UN agencies (US$) of 1972?
Your answer should be very brief. 1.90e+07. What is the difference between the highest and the lowest Aid flow from UN agencies (US$) of 1969?
Provide a short and direct response. 4.99e+07. What is the difference between the highest and the lowest Aid flow from UN agencies (US$) in 1970?
Provide a short and direct response. 9.31e+07. What is the difference between the highest and the lowest Aid flow from UN agencies (US$) in 1971?
Your answer should be compact. 1.22e+08. What is the difference between the highest and the lowest Aid flow from UN agencies (US$) of 1972?
Give a very brief answer. 9.40e+07. 